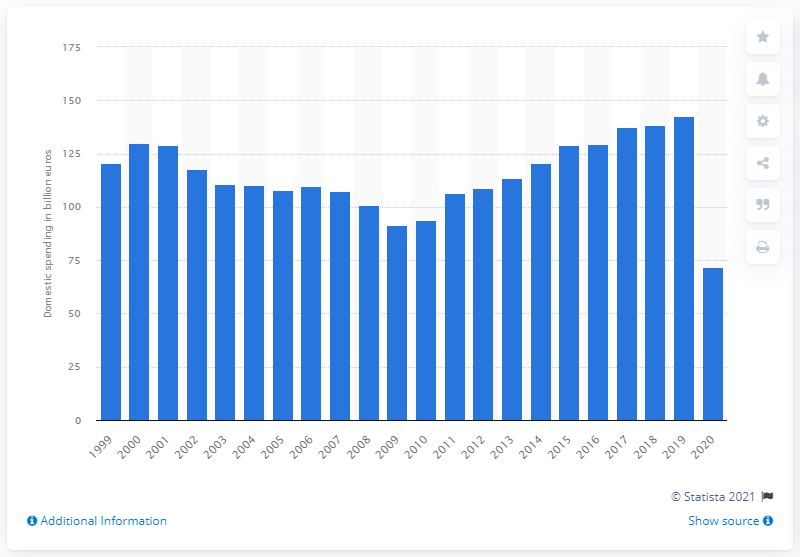List a handful of essential elements in this visual. In 2019, the total expenditure of domestic tourists in Italy was 142.8 billion euros. In 2020, the total expenditure of domestic tourists in Italy was 71.9 billion euros. 